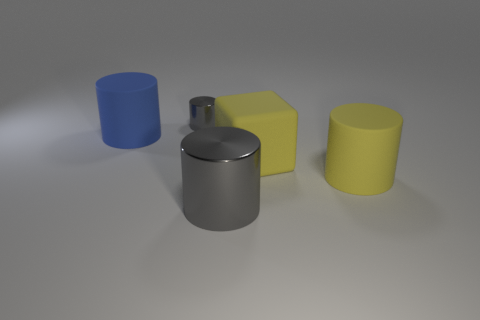Subtract all yellow cylinders. How many cylinders are left? 3 Subtract all big gray metallic cylinders. How many cylinders are left? 3 Subtract all cylinders. How many objects are left? 1 Subtract 1 cubes. How many cubes are left? 0 Add 4 yellow metal cubes. How many objects exist? 9 Subtract all purple balls. How many yellow cylinders are left? 1 Subtract all metallic cylinders. Subtract all tiny gray cylinders. How many objects are left? 2 Add 2 cylinders. How many cylinders are left? 6 Add 5 tiny cyan shiny cubes. How many tiny cyan shiny cubes exist? 5 Subtract 0 cyan blocks. How many objects are left? 5 